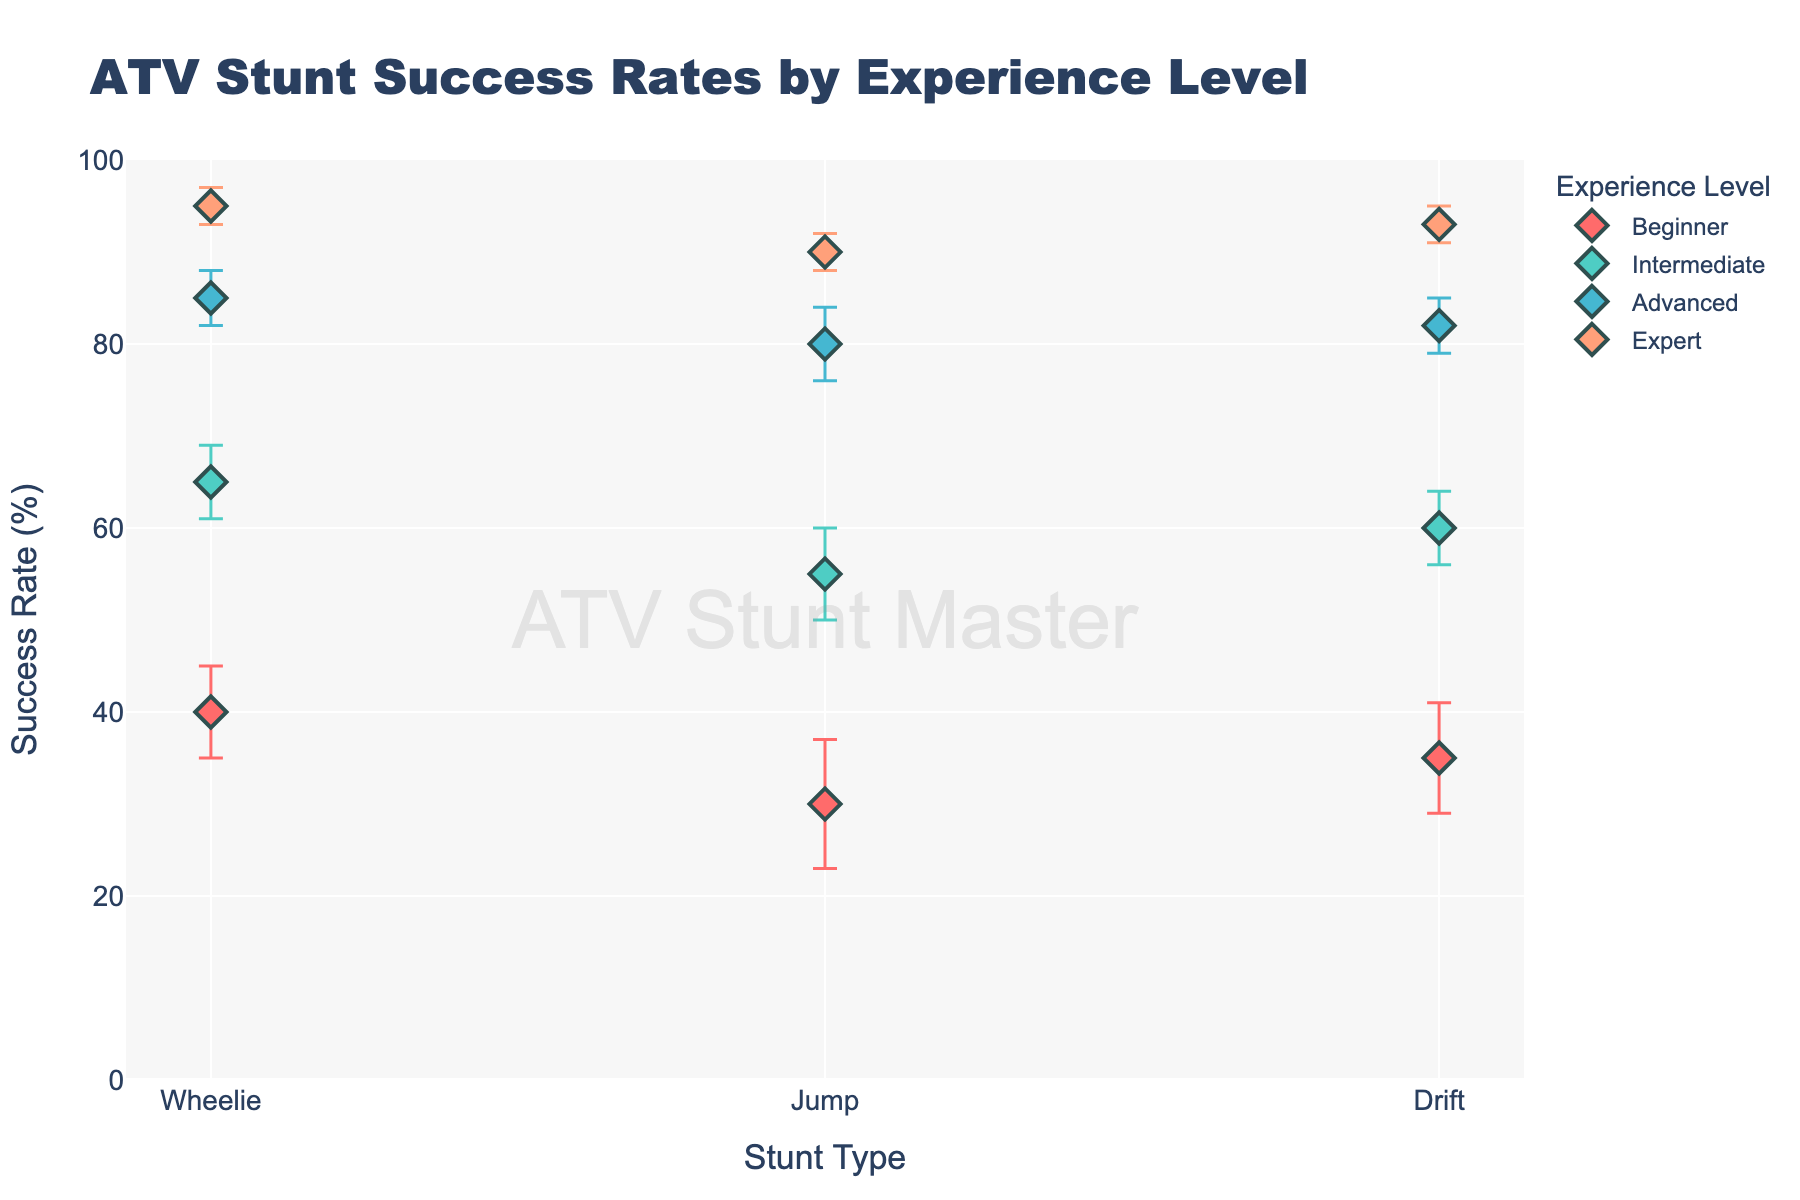What is the title of the chart? The title is typically placed at the top of the chart. Here, the title text is shown as 'ATV Stunt Success Rates by Experience Level'.
Answer: ATV Stunt Success Rates by Experience Level Which experience level has the highest success rate for the 'Wheelie' stunt? By inspecting the y-axis values of the 'Wheelie' stunt points for each experience level, the 'Expert' level has the highest success rate at 95%.
Answer: Expert What is the range of success rates for the 'Intermediate' experience level across all stunts? The 'Intermediate' success rates for 'Wheelie', 'Jump', and 'Drift' are 65%, 55%, and 60%, respectively. Thus, the range is the difference between the highest and lowest values: 65% - 55% = 10%.
Answer: 10% Which stunt type shows the most significant improvement in success rate from 'Beginner' to 'Expert'? Comparing the success rates across experience levels for each stunt:
- Wheelie: 95% (Expert) - 40% (Beginner) = 55%
- Jump: 90% (Expert) - 30% (Beginner) = 60%
- Drift: 93% (Expert) - 35% (Beginner) = 58%
The stunt with the largest difference is 'Jump'.
Answer: Jump How does the margin of error for 'Expert' riders compare to that for 'Beginner' riders across all stunt types? By examining the error bars:
- 'Expert' has margins of error of 2% for all stunts.
- 'Beginner' has margins of error, respectively, of 5% (Wheelie), 7% (Jump), and 6% (Drift).
Hence, the margins of error are consistently smaller for 'Expert' riders.
Answer: Smaller for Experts What is the average success rate of 'Advanced' riders across all stunt types? The success rates for 'Advanced' riders are 85% (Wheelie), 80% (Jump), and 82% (Drift). Adding them up: 85 + 80 + 82 = 247. Then, dividing by the number of stunts (3), we get 247/3 = 82.33%.
Answer: 82.33% Which stunt type has the smallest variation in success rate across all experience levels? Calculating the variance for each stunt:
- Wheelie: Range = 95% (Expert) - 40% (Beginner) = 55%
- Jump: Range = 90% (Expert) - 30% (Beginner) = 60%
- Drift: Range = 93% (Expert) - 35% (Beginner) = 58%
Thus, 'Wheelie' has the smallest range, indicating the smallest variation.
Answer: Wheelie Among 'Beginner' and 'Intermediate' riders, which experience level has higher success rates for 'Drift' and by how much? 'Beginner' has a success rate of 35% for 'Drift', while 'Intermediate' has 60%. The difference is 60% - 35% = 25%.
Answer: Intermediate by 25% 